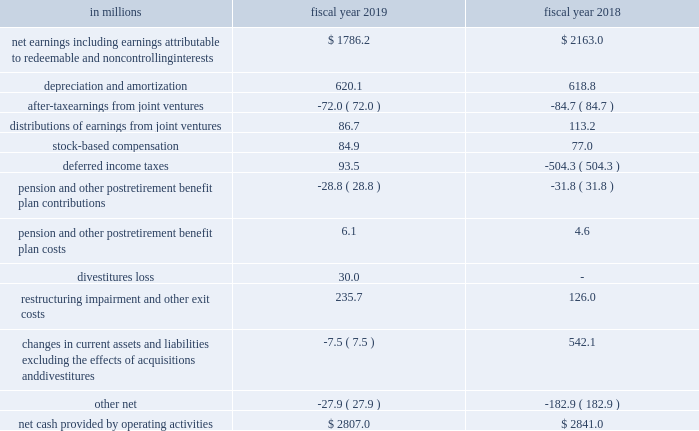Liquidity the primary source of our liquidity is cash flow from operations .
Over the most recent two-year period , our operations have generated $ 5.6 billion in cash .
A substantial portion of this operating cash flow has been returned to shareholders through share repurchases and dividends .
We also use cash from operations to fund our capital expenditures and acquisitions .
We typically use a combination of cash , notes payable , and long-term debt , and occasionally issue shares of stock , to finance significant acquisitions .
As of may 26 , 2019 , we had $ 399 million of cash and cash equivalents held in foreign jurisdictions .
As a result of the tcja , the historic undistributed earnings of our foreign subsidiaries were taxed in the u.s .
Via the one-time repatriation tax in fiscal 2018 .
We have re-evaluated our assertion and have concluded that although earnings prior to fiscal 2018 will remain permanently reinvested , we will no longer make a permanent reinvestment assertion beginning with our fiscal 2018 earnings .
As part of the accounting for the tcja , we recorded local country withholding taxes related to certain entities from which we began repatriating undistributed earnings and will continue to record local country withholding taxes on all future earnings .
As a result of the transition tax , we may repatriate our cash and cash equivalents held by our foreign subsidiaries without such funds being subject to further u.s .
Income tax liability ( please see note 14 to the consolidated financial statements in item 8 of this report for additional information ) .
Cash flows from operations .
During fiscal 2019 , cash provided by operations was $ 2807 million compared to $ 2841 million in the same period last year .
The $ 34 million decrease was primarily driven by a $ 377 million decrease in net earnings and a $ 550 million change in current assets and liabilities , partially offset by a $ 598 million change in deferred income taxes .
The $ 550 million change in current assets and liabilities was primarily driven by a $ 413 million change in the timing of accounts payable , including the impact of longer payment terms implemented in prior fiscal years .
The change in deferred income taxes was primarily related to the $ 638 million provisional benefit from revaluing our net u.s .
Deferred tax liabilities to reflect the new u.s .
Corporate tax rate as a result of the tcja in fiscal we strive to grow core working capital at or below the rate of growth in our net sales .
For fiscal 2019 , core working capital decreased 34 percent , compared to a net sales increase of 7 percent .
As of may 26 , 2019 , our core working capital balance totaled $ 385 million , down 34 percent versus last year , this is primarily driven by continued benefits from our payment terms extension program and lower inventory balances .
In fiscal 2018 , core working capital decreased 27 percent , compared to a net sales increase of 1 percent. .
During fiscal 2019 , what was the percent of the change in the cash provided by operations? 
Computations: ((2807 - 2841) / 2841)
Answer: -0.01197. Liquidity the primary source of our liquidity is cash flow from operations .
Over the most recent two-year period , our operations have generated $ 5.6 billion in cash .
A substantial portion of this operating cash flow has been returned to shareholders through share repurchases and dividends .
We also use cash from operations to fund our capital expenditures and acquisitions .
We typically use a combination of cash , notes payable , and long-term debt , and occasionally issue shares of stock , to finance significant acquisitions .
As of may 26 , 2019 , we had $ 399 million of cash and cash equivalents held in foreign jurisdictions .
As a result of the tcja , the historic undistributed earnings of our foreign subsidiaries were taxed in the u.s .
Via the one-time repatriation tax in fiscal 2018 .
We have re-evaluated our assertion and have concluded that although earnings prior to fiscal 2018 will remain permanently reinvested , we will no longer make a permanent reinvestment assertion beginning with our fiscal 2018 earnings .
As part of the accounting for the tcja , we recorded local country withholding taxes related to certain entities from which we began repatriating undistributed earnings and will continue to record local country withholding taxes on all future earnings .
As a result of the transition tax , we may repatriate our cash and cash equivalents held by our foreign subsidiaries without such funds being subject to further u.s .
Income tax liability ( please see note 14 to the consolidated financial statements in item 8 of this report for additional information ) .
Cash flows from operations .
During fiscal 2019 , cash provided by operations was $ 2807 million compared to $ 2841 million in the same period last year .
The $ 34 million decrease was primarily driven by a $ 377 million decrease in net earnings and a $ 550 million change in current assets and liabilities , partially offset by a $ 598 million change in deferred income taxes .
The $ 550 million change in current assets and liabilities was primarily driven by a $ 413 million change in the timing of accounts payable , including the impact of longer payment terms implemented in prior fiscal years .
The change in deferred income taxes was primarily related to the $ 638 million provisional benefit from revaluing our net u.s .
Deferred tax liabilities to reflect the new u.s .
Corporate tax rate as a result of the tcja in fiscal we strive to grow core working capital at or below the rate of growth in our net sales .
For fiscal 2019 , core working capital decreased 34 percent , compared to a net sales increase of 7 percent .
As of may 26 , 2019 , our core working capital balance totaled $ 385 million , down 34 percent versus last year , this is primarily driven by continued benefits from our payment terms extension program and lower inventory balances .
In fiscal 2018 , core working capital decreased 27 percent , compared to a net sales increase of 1 percent. .
What was the change in the net earnings from 2018 to 2019 in million? 
Computations: (1786.2 - 2163.0)
Answer: -376.8. 